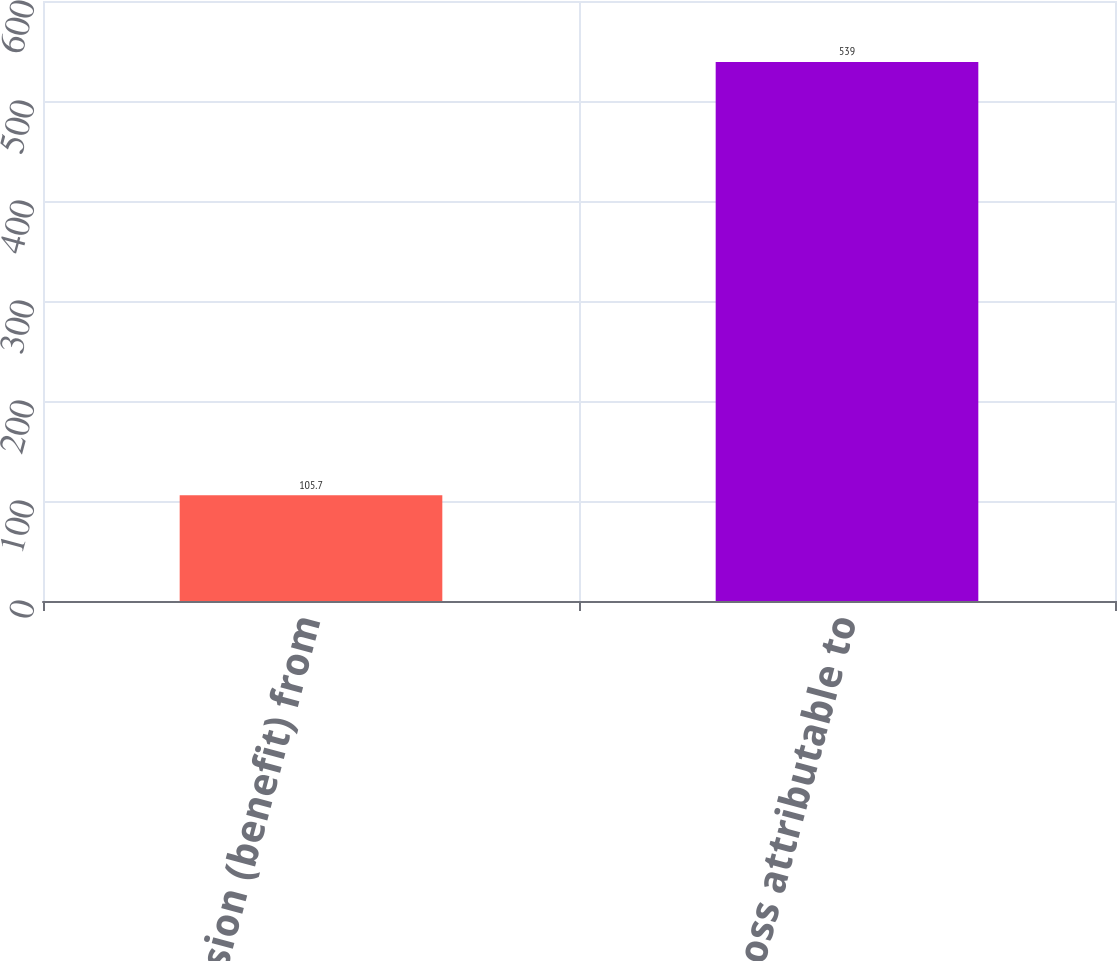Convert chart to OTSL. <chart><loc_0><loc_0><loc_500><loc_500><bar_chart><fcel>Provision (benefit) from<fcel>Net loss attributable to<nl><fcel>105.7<fcel>539<nl></chart> 